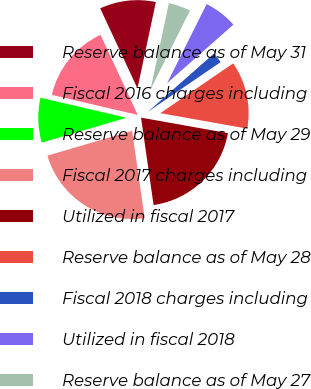<chart> <loc_0><loc_0><loc_500><loc_500><pie_chart><fcel>Reserve balance as of May 31<fcel>Fiscal 2016 charges including<fcel>Reserve balance as of May 29<fcel>Fiscal 2017 charges including<fcel>Utilized in fiscal 2017<fcel>Reserve balance as of May 28<fcel>Fiscal 2018 charges including<fcel>Utilized in fiscal 2018<fcel>Reserve balance as of May 27<nl><fcel>10.27%<fcel>14.42%<fcel>8.19%<fcel>22.73%<fcel>19.92%<fcel>12.35%<fcel>1.96%<fcel>6.12%<fcel>4.04%<nl></chart> 